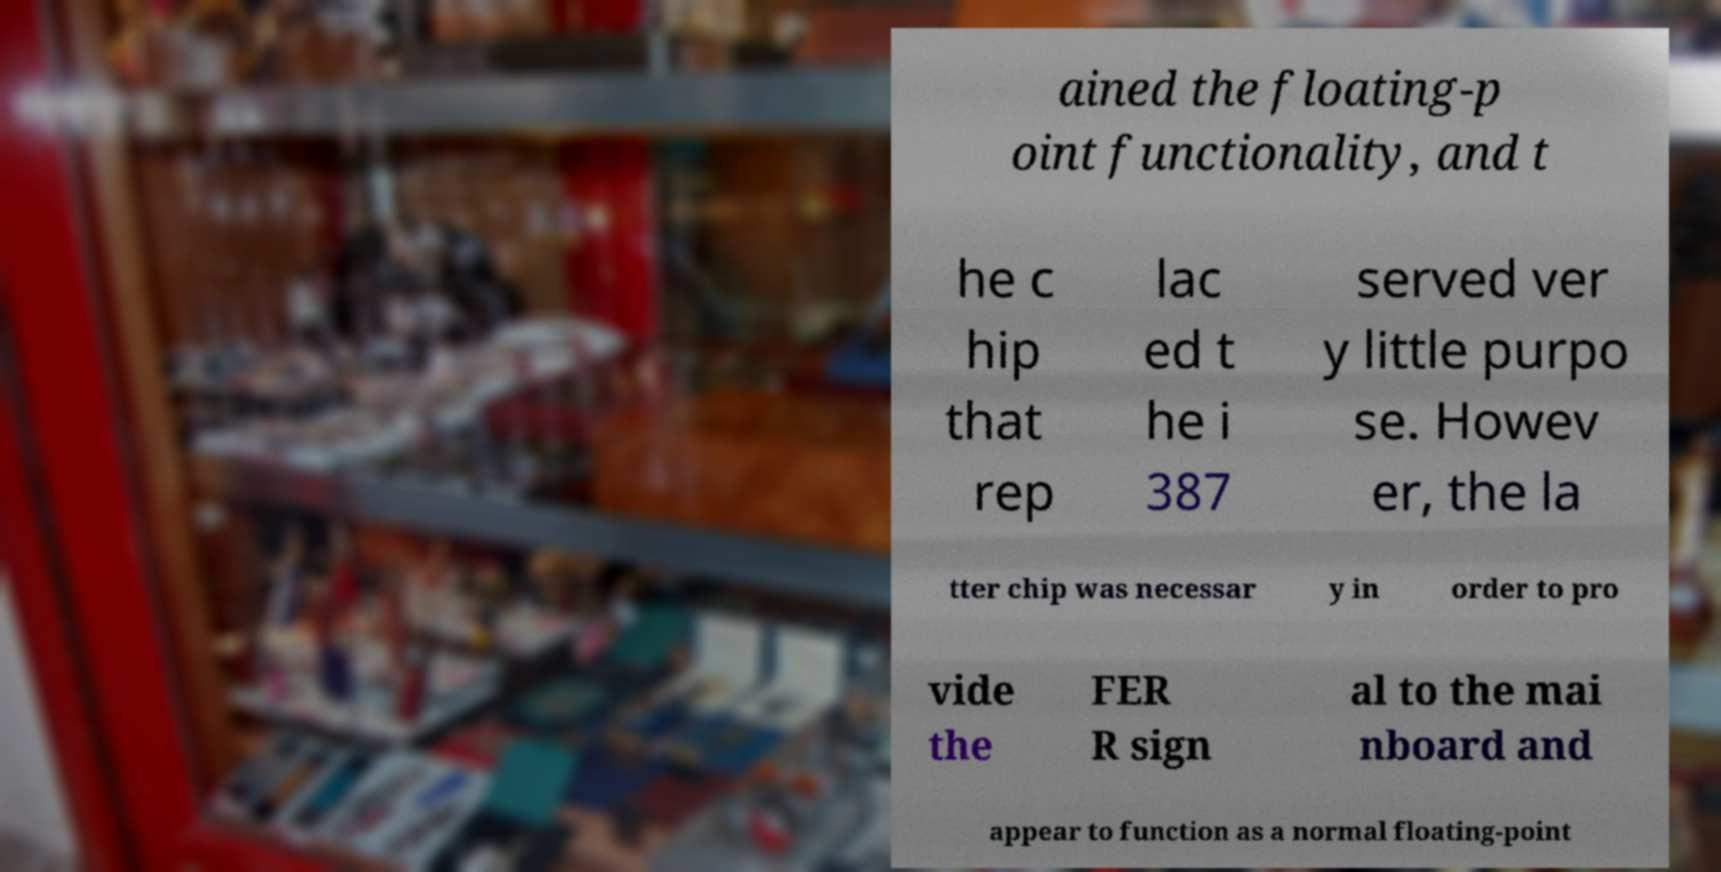There's text embedded in this image that I need extracted. Can you transcribe it verbatim? ained the floating-p oint functionality, and t he c hip that rep lac ed t he i 387 served ver y little purpo se. Howev er, the la tter chip was necessar y in order to pro vide the FER R sign al to the mai nboard and appear to function as a normal floating-point 